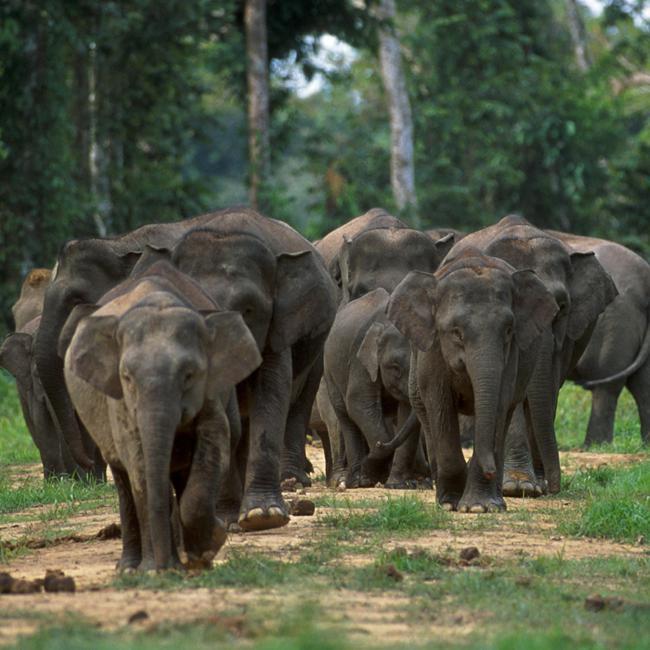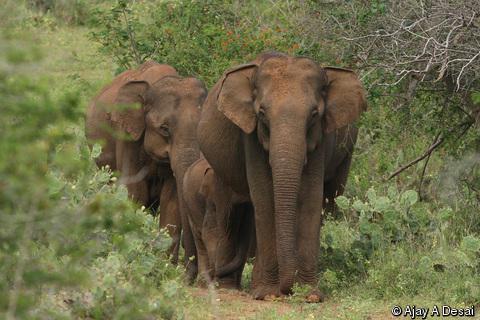The first image is the image on the left, the second image is the image on the right. Considering the images on both sides, is "The right image contains exactly one elephant." valid? Answer yes or no. No. The first image is the image on the left, the second image is the image on the right. Analyze the images presented: Is the assertion "There are two elephanfs in the image pair." valid? Answer yes or no. No. 